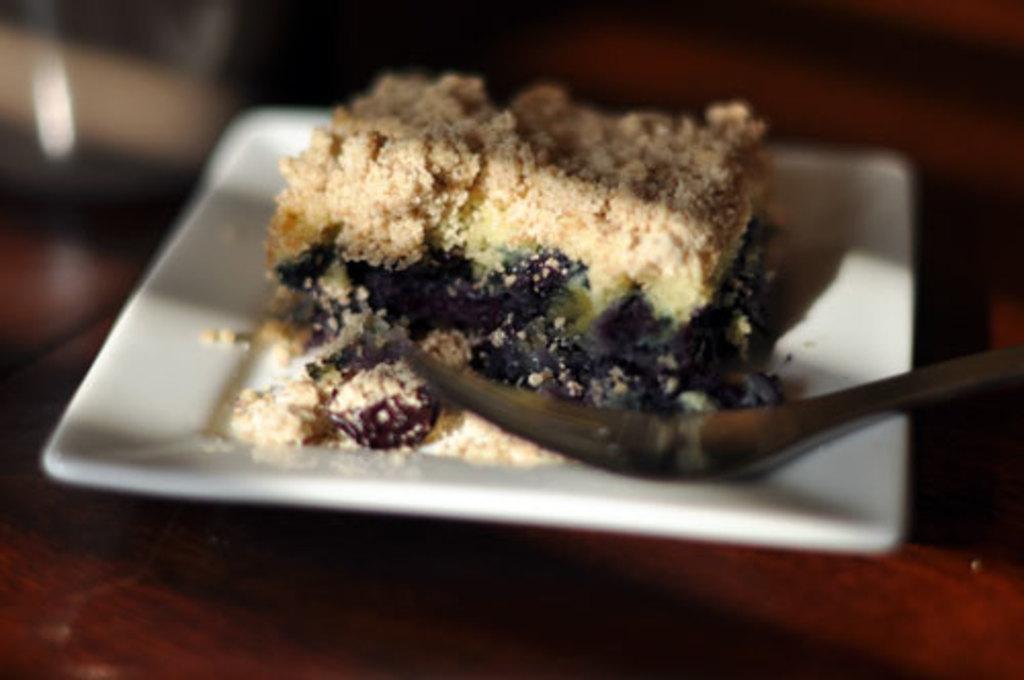Please provide a concise description of this image. In this image there is a plate on the wooden surface. On the plate there is food. Beside the food there is a fork on the plate. At the top it is blurry. 